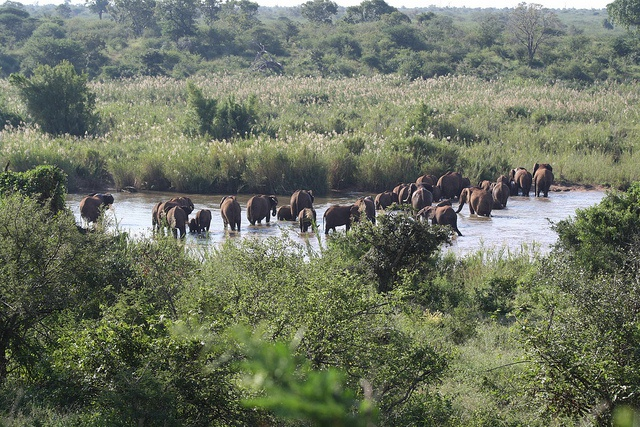Describe the objects in this image and their specific colors. I can see elephant in white, black, gray, and darkgray tones, elephant in white, black, gray, and darkgray tones, elephant in white, black, and gray tones, elephant in white, black, gray, and darkgray tones, and elephant in white, black, gray, and darkgray tones in this image. 